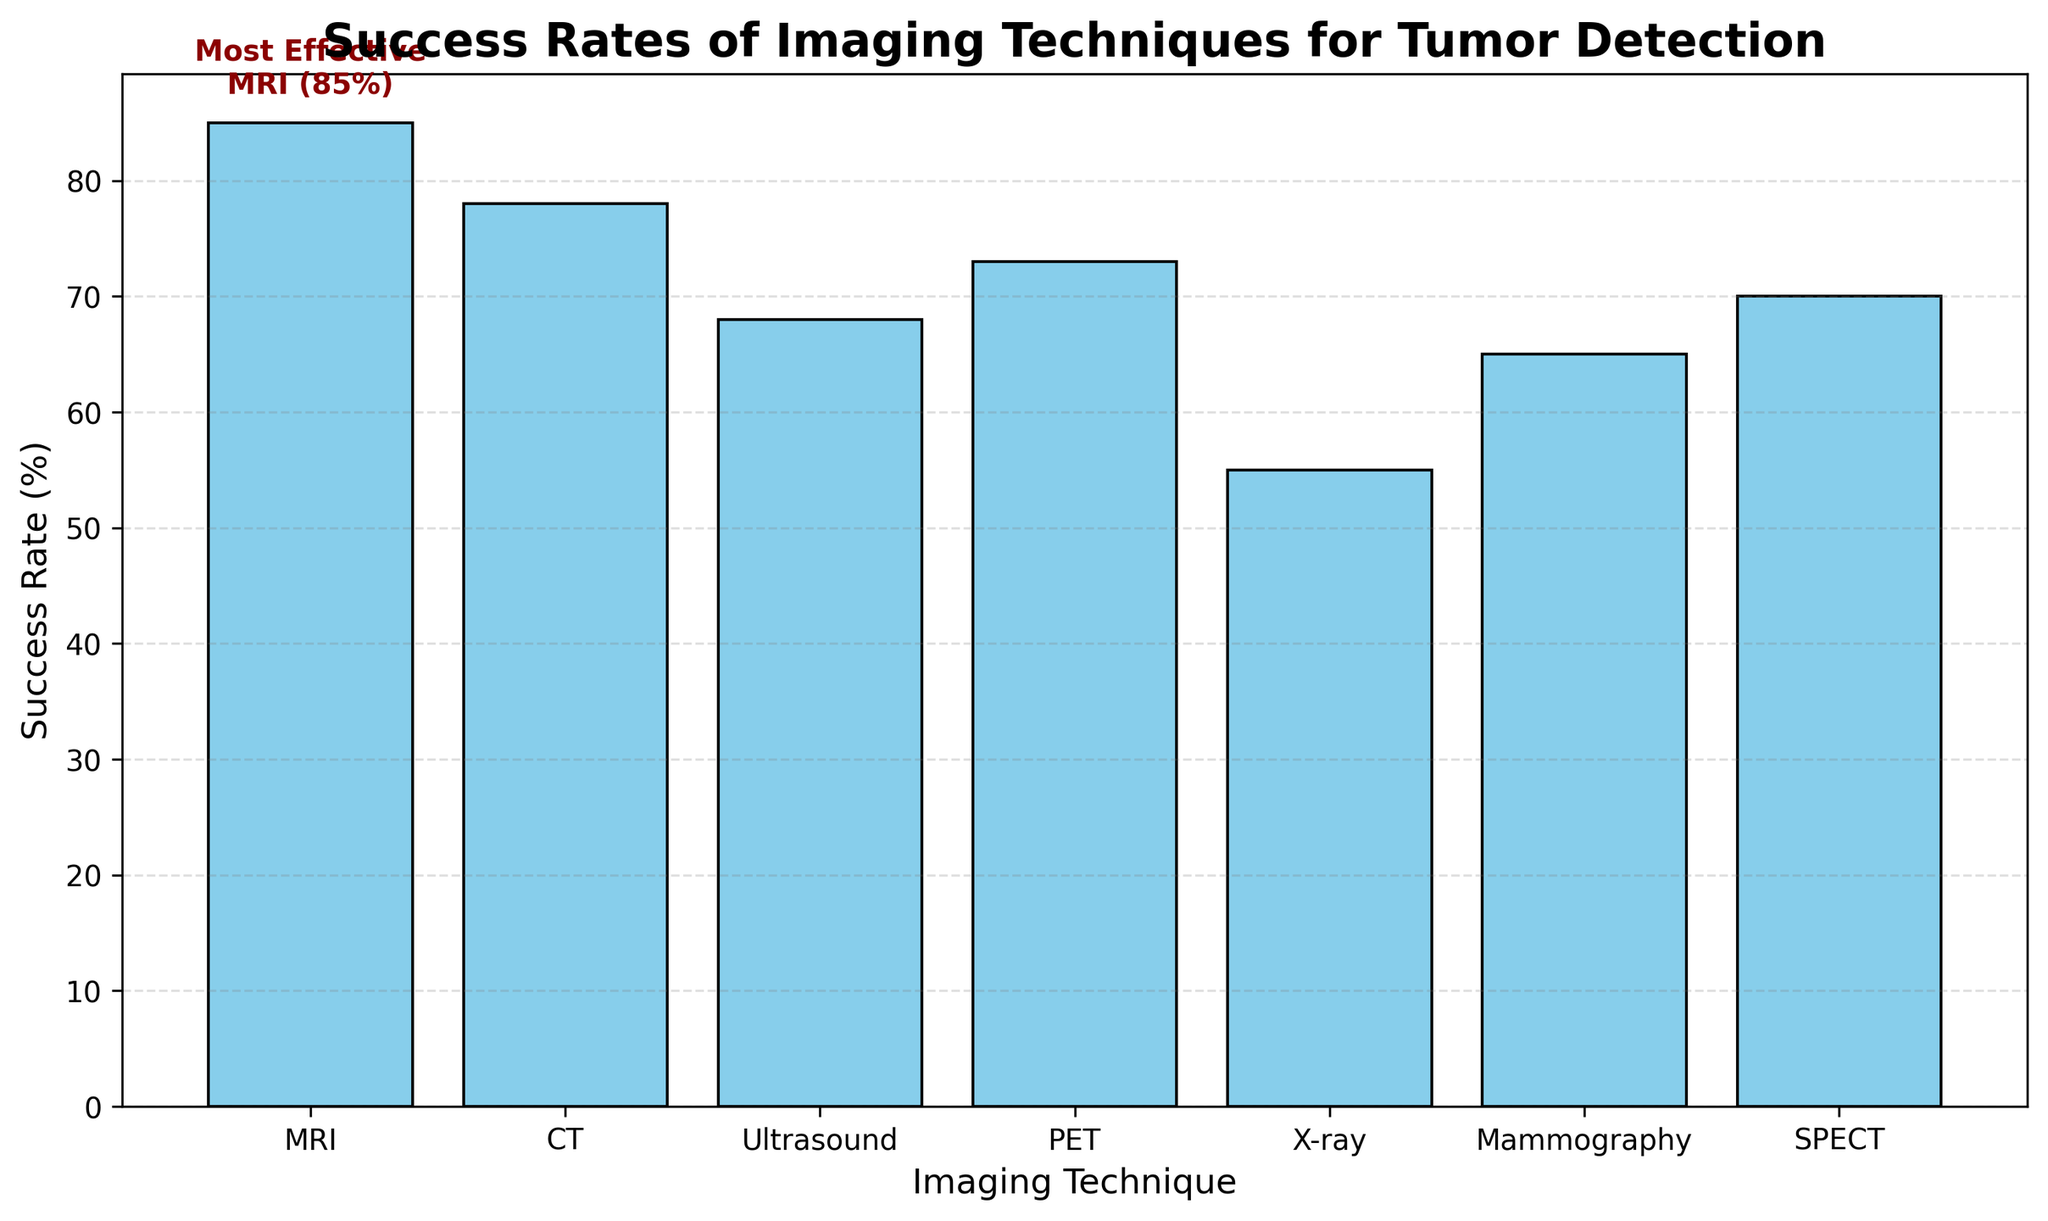What is the most effective imaging technique for tumor detection? The figure has a text annotation stating "Most Effective MRI (85%)" above the MRI bar, clearly indicating it as the highest.
Answer: MRI Which imaging technique has the lowest success rate? By visually scanning the heights of the bars, the X-ray bar is the shortest, indicating it has the lowest success rate.
Answer: X-ray What is the difference in success rate between MRI and ultrasound? The success rate for MRI is 85% and for ultrasound is 68%. The difference is 85% - 68% = 17%.
Answer: 17% Which imaging technique is more effective, PET or SPECT? Comparing the heights of the bars for PET and SPECT, PET (73%) is slightly higher than SPECT (70%).
Answer: PET What is the total success rate if you combine CT and mammography? The success rate for CT is 78% and for mammography is 65%. Combining them gives 78% + 65% = 143%.
Answer: 143% What is the average success rate of all imaging techniques? Add all the success rates: (85 + 78 + 68 + 73 + 55 + 65 + 70) = 494. There are 7 techniques, so the average is 494 / 7 ≈ 70.57%.
Answer: 70.57% Is ultrasound more or less effective than half the success rate of MRI? Half the success rate of MRI is 85% / 2 = 42.5%. Since ultrasound has a success rate of 68%, it is more effective.
Answer: More effective How does the success rate of MRI compare to the combined success rate of ultrasound and mammography? MRI is 85%. Combining ultrasound (68%) and mammography (65%) gives 68% + 65% = 133%. MRI's success rate is less than the combined rate.
Answer: Less Which imaging techniques have a success rate below 70%? By looking at the bars below the 70% mark, ultrasound (68%), X-ray (55%), and mammography (65%) fall below this threshold.
Answer: Ultrasound, X-ray, Mammography How much higher is the success rate of MRI compared to the average success rate of the other techniques? The average success rate of other techniques is (78 + 68 + 73 + 55 + 65 + 70) / 6 ≈ 68.17%. MRI's rate is 85%. The difference is 85% - 68.17% = 16.83%.
Answer: 16.83% 